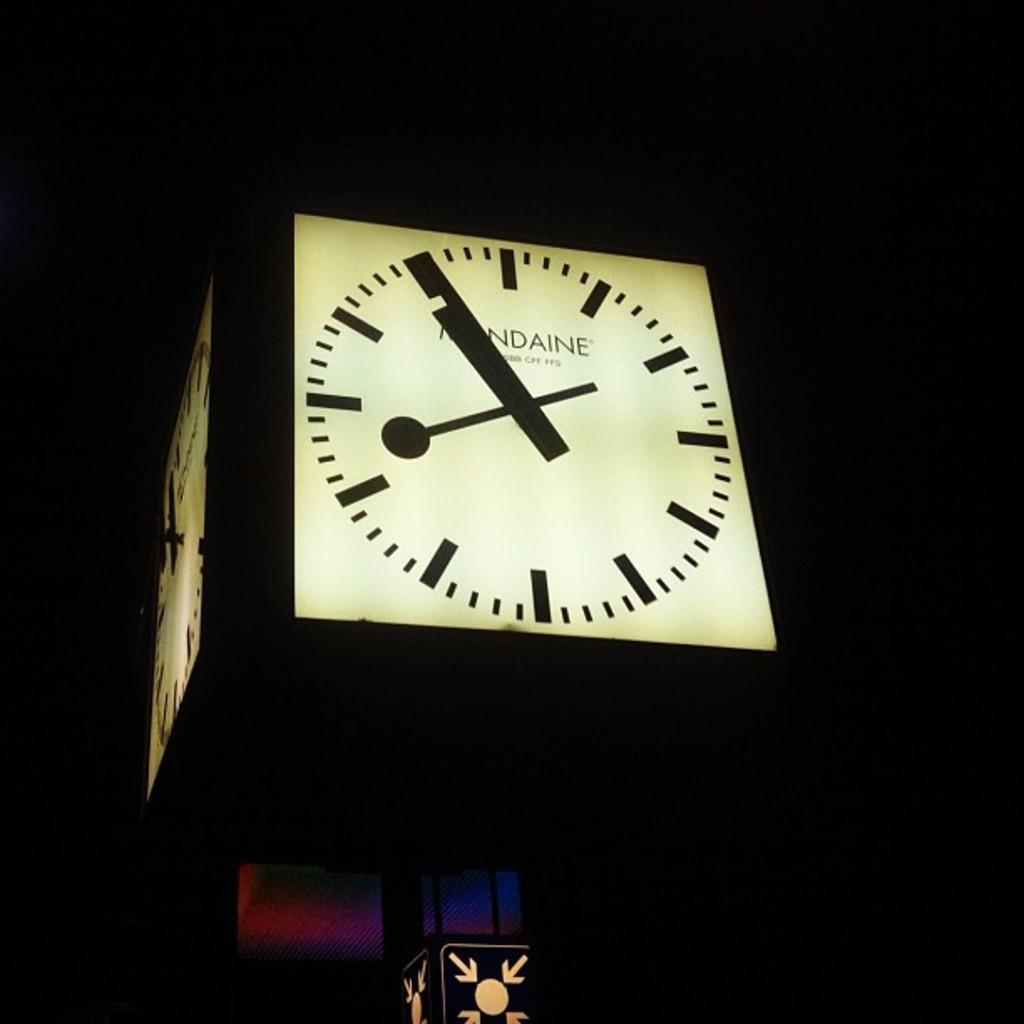<image>
Describe the image concisely. The time on the clock tower is 8:55 PM. 